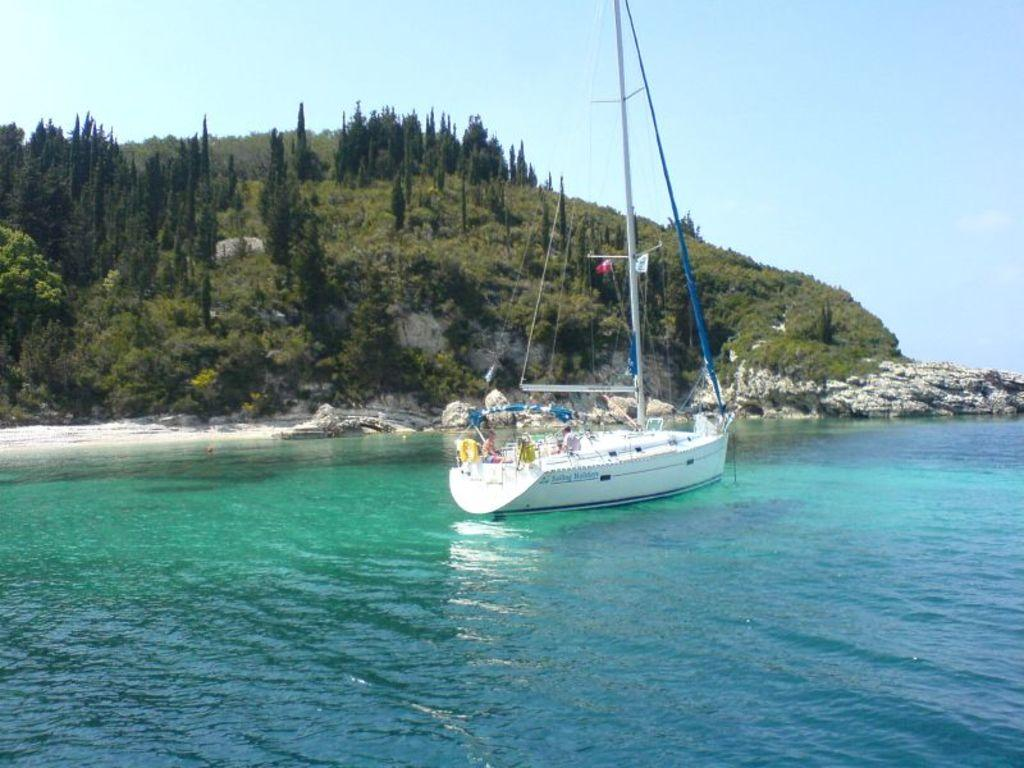What is in the water in the image? There is a boat in the water in the image. Who or what is inside the boat? There are people seated in the boat. What can be seen in the background of the image? There are rocks and trees visible in the background. What type of patch is being used to fix the crown in the image? There is no patch or crown present in the image; it features a boat with people in it and a background with rocks and trees. 